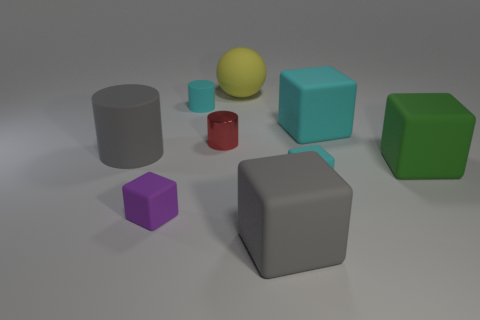Is there an object that stands out from the rest due to its color or size? Yes, the medium-sized yellow sphere stands out due to its vibrant color and central position. Its spherical shape contrasts with the angular cubes and cylinders, making it a focal point of the composition. 